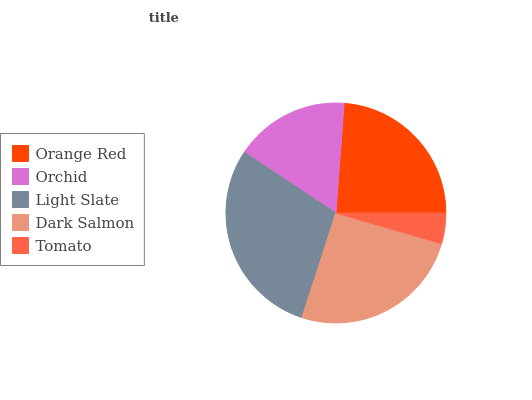Is Tomato the minimum?
Answer yes or no. Yes. Is Light Slate the maximum?
Answer yes or no. Yes. Is Orchid the minimum?
Answer yes or no. No. Is Orchid the maximum?
Answer yes or no. No. Is Orange Red greater than Orchid?
Answer yes or no. Yes. Is Orchid less than Orange Red?
Answer yes or no. Yes. Is Orchid greater than Orange Red?
Answer yes or no. No. Is Orange Red less than Orchid?
Answer yes or no. No. Is Orange Red the high median?
Answer yes or no. Yes. Is Orange Red the low median?
Answer yes or no. Yes. Is Dark Salmon the high median?
Answer yes or no. No. Is Dark Salmon the low median?
Answer yes or no. No. 